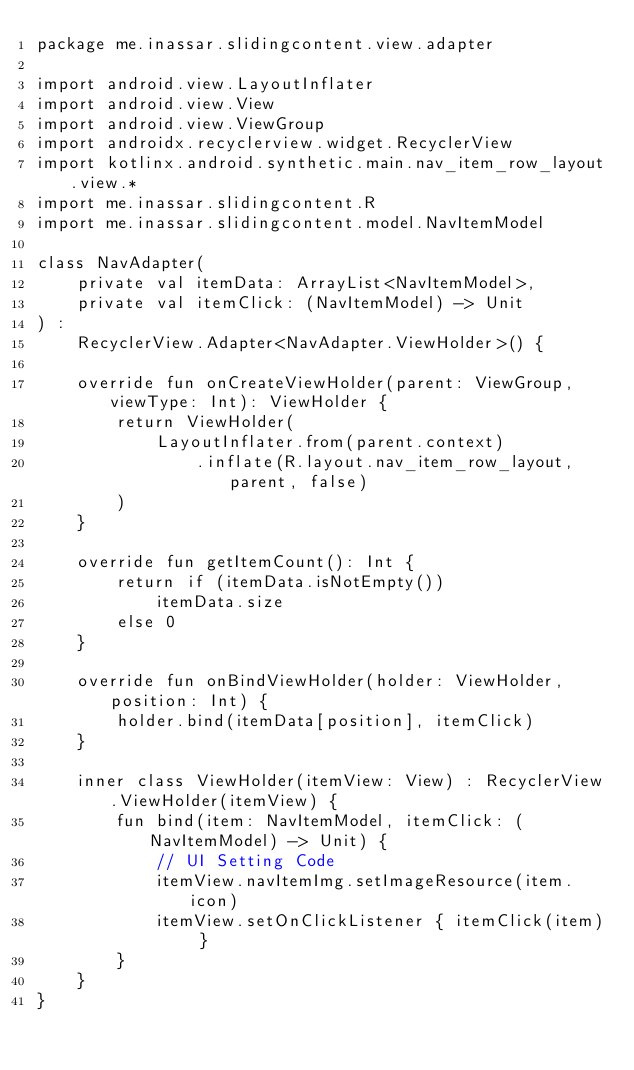<code> <loc_0><loc_0><loc_500><loc_500><_Kotlin_>package me.inassar.slidingcontent.view.adapter

import android.view.LayoutInflater
import android.view.View
import android.view.ViewGroup
import androidx.recyclerview.widget.RecyclerView
import kotlinx.android.synthetic.main.nav_item_row_layout.view.*
import me.inassar.slidingcontent.R
import me.inassar.slidingcontent.model.NavItemModel

class NavAdapter(
    private val itemData: ArrayList<NavItemModel>,
    private val itemClick: (NavItemModel) -> Unit
) :
    RecyclerView.Adapter<NavAdapter.ViewHolder>() {

    override fun onCreateViewHolder(parent: ViewGroup, viewType: Int): ViewHolder {
        return ViewHolder(
            LayoutInflater.from(parent.context)
                .inflate(R.layout.nav_item_row_layout, parent, false)
        )
    }

    override fun getItemCount(): Int {
        return if (itemData.isNotEmpty())
            itemData.size
        else 0
    }

    override fun onBindViewHolder(holder: ViewHolder, position: Int) {
        holder.bind(itemData[position], itemClick)
    }

    inner class ViewHolder(itemView: View) : RecyclerView.ViewHolder(itemView) {
        fun bind(item: NavItemModel, itemClick: (NavItemModel) -> Unit) {
            // UI Setting Code
            itemView.navItemImg.setImageResource(item.icon)
            itemView.setOnClickListener { itemClick(item) }
        }
    }
}
</code> 